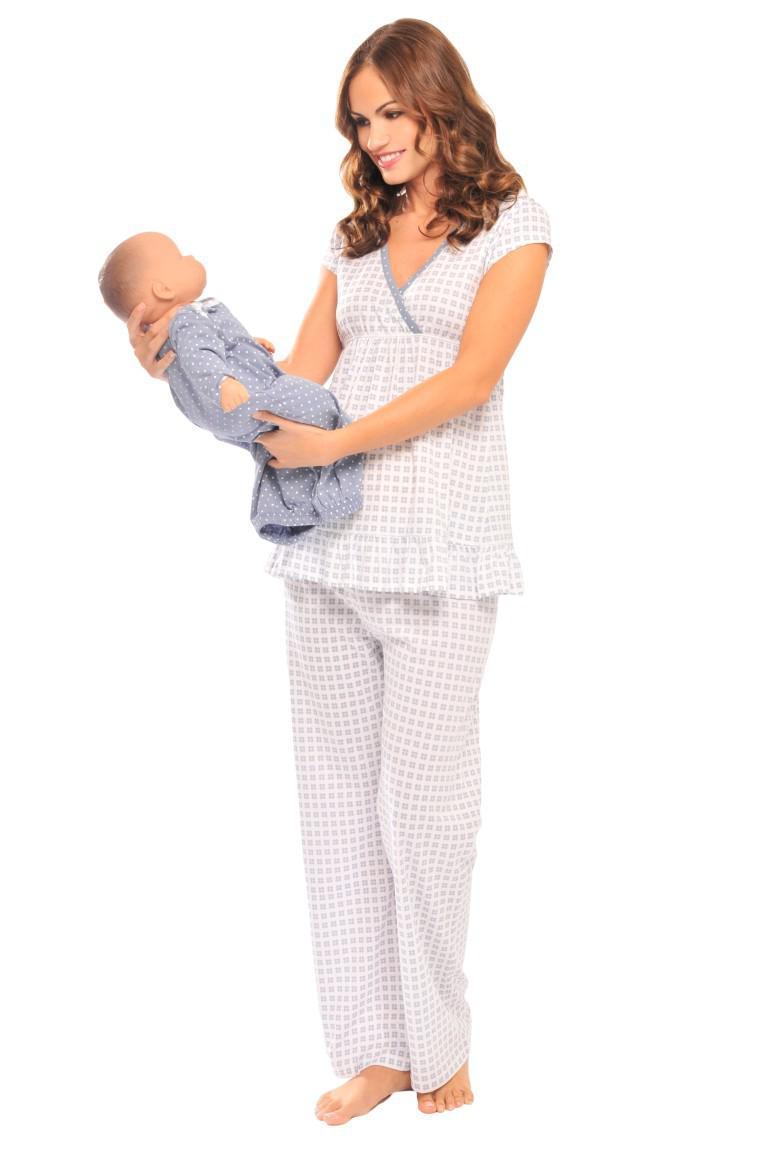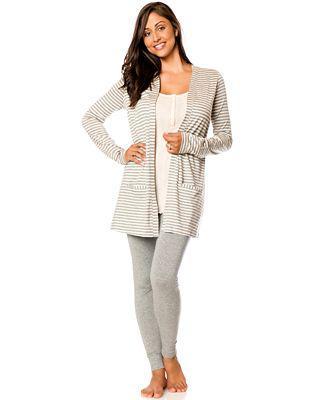The first image is the image on the left, the second image is the image on the right. For the images displayed, is the sentence "One women's pajama outfit has a matching short robe." factually correct? Answer yes or no. Yes. 